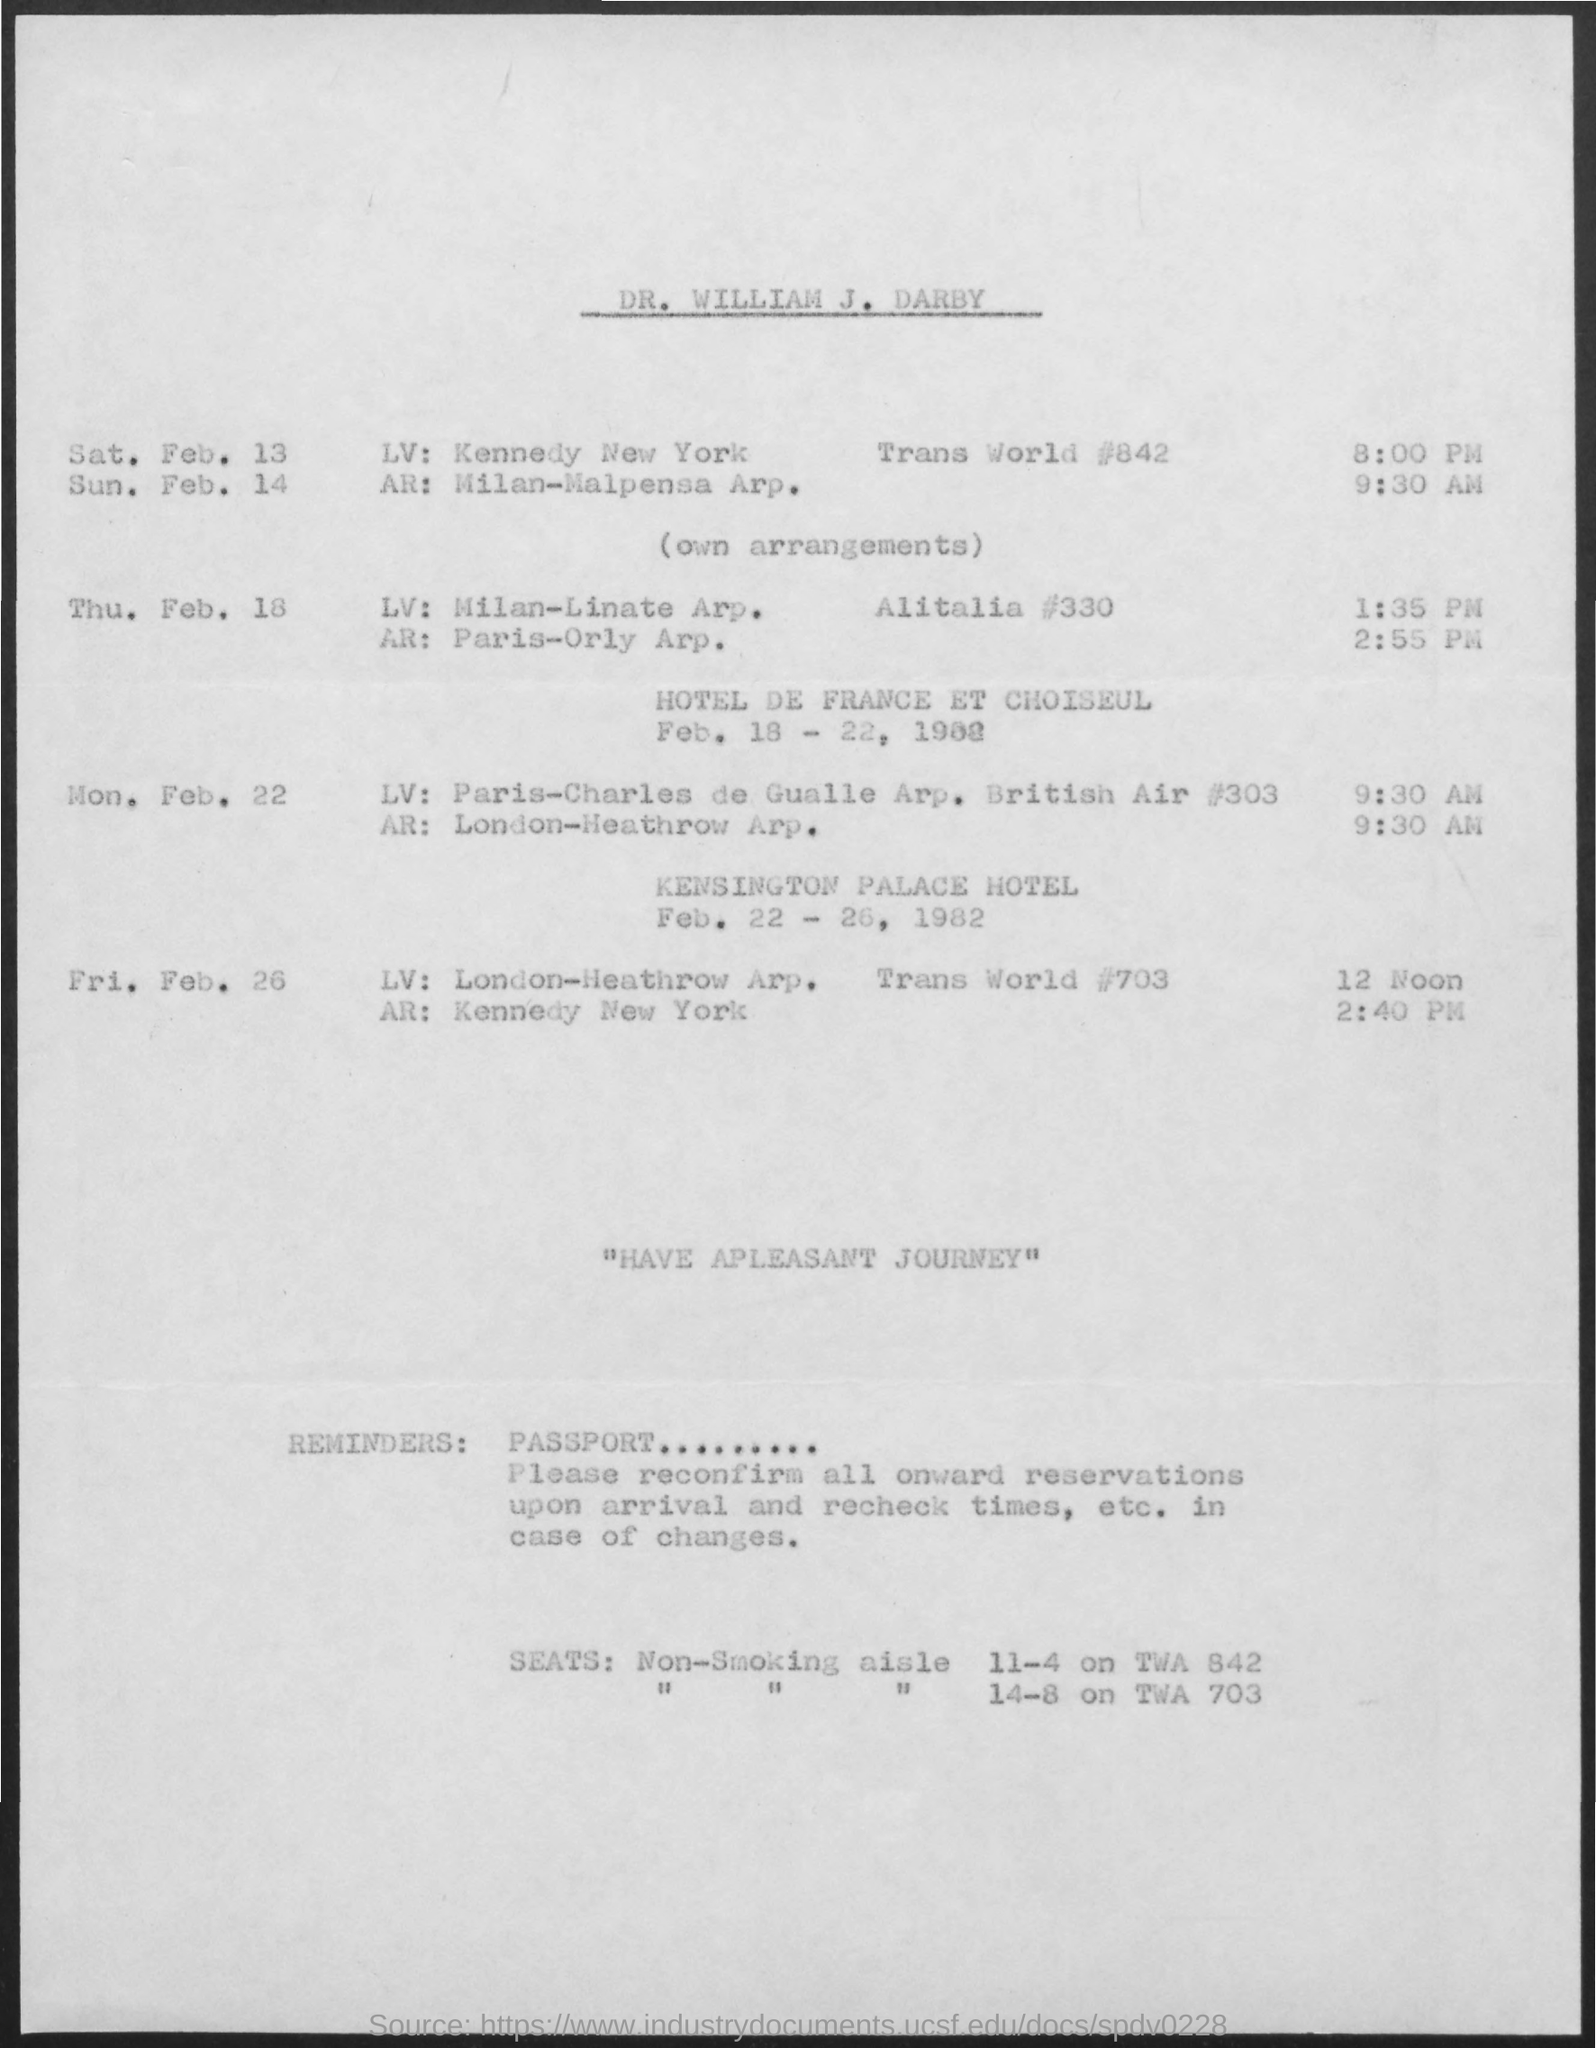Give some essential details in this illustration. The title of the document is "DR. William J. Darby. 